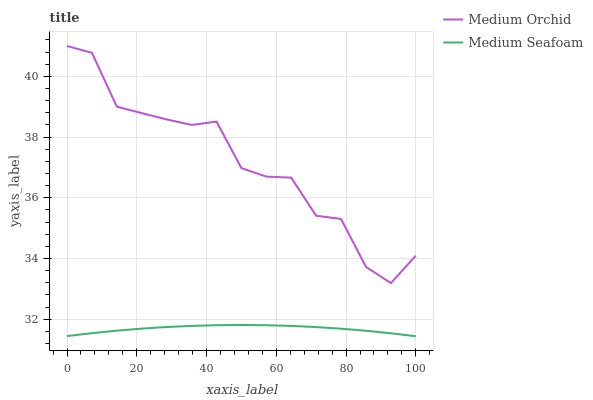Does Medium Seafoam have the minimum area under the curve?
Answer yes or no. Yes. Does Medium Orchid have the maximum area under the curve?
Answer yes or no. Yes. Does Medium Seafoam have the maximum area under the curve?
Answer yes or no. No. Is Medium Seafoam the smoothest?
Answer yes or no. Yes. Is Medium Orchid the roughest?
Answer yes or no. Yes. Is Medium Seafoam the roughest?
Answer yes or no. No. Does Medium Seafoam have the lowest value?
Answer yes or no. Yes. Does Medium Orchid have the highest value?
Answer yes or no. Yes. Does Medium Seafoam have the highest value?
Answer yes or no. No. Is Medium Seafoam less than Medium Orchid?
Answer yes or no. Yes. Is Medium Orchid greater than Medium Seafoam?
Answer yes or no. Yes. Does Medium Seafoam intersect Medium Orchid?
Answer yes or no. No. 